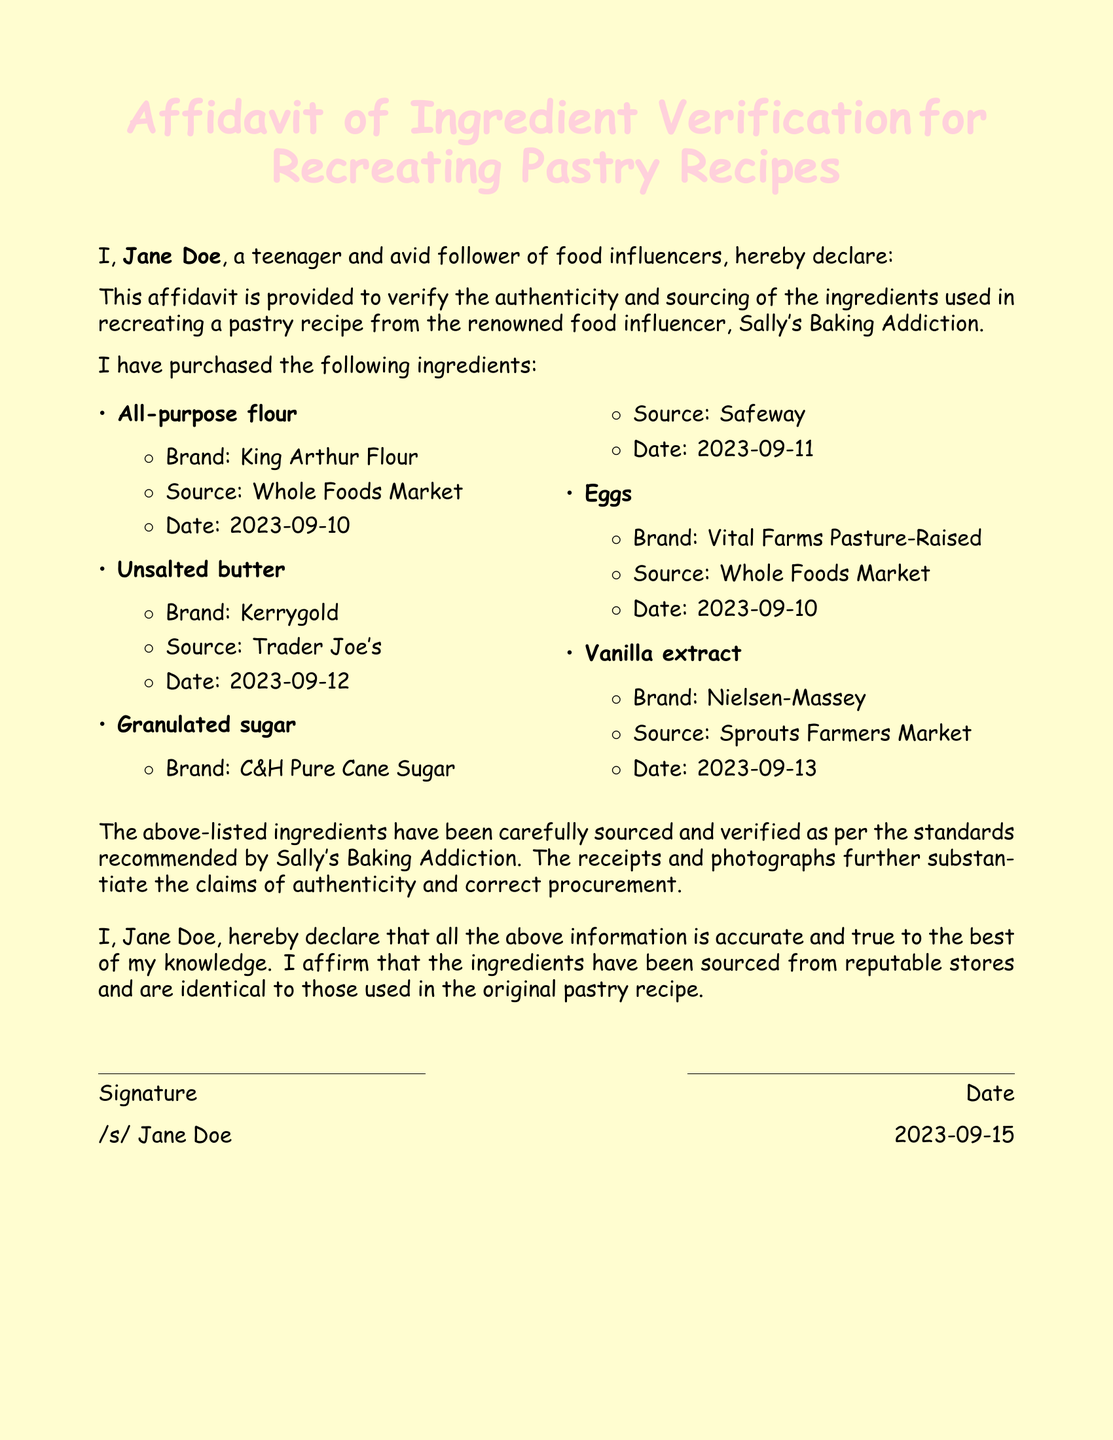What is the name of the affidavit? The name of the affidavit is provided at the top as "Affidavit of Ingredient Verification for Recreating Pastry Recipes."
Answer: Affidavit of Ingredient Verification for Recreating Pastry Recipes Who is the signer of the affidavit? The signer is identified in the document as "Jane Doe."
Answer: Jane Doe What brand of flour was used? The document states the brand of flour used is "King Arthur Flour."
Answer: King Arthur Flour What is the date of purchase for the eggs? The purchase date for the eggs is explicitly mentioned in the document as "2023-09-10."
Answer: 2023-09-10 Which market sourced the unsalted butter? The document notes that the unsalted butter was sourced from "Trader Joe's."
Answer: Trader Joe's How many ingredients were listed in total? The document lists a total of five distinct ingredients used in the recipe.
Answer: 5 What date was the affidavit signed? The date on which the affidavit was signed is recorded as "2023-09-15."
Answer: 2023-09-15 What is included to support the claims of authenticity? The document mentions "receipts and photographs" to support the authenticity claims.
Answer: receipts and photographs Is there a statement of truth regarding the information? The document contains an affirmation from the signer regarding the accuracy of the information provided.
Answer: Yes, there is a statement of truth 